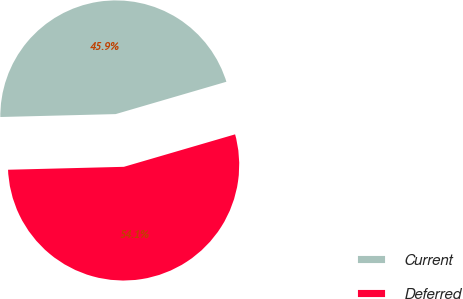<chart> <loc_0><loc_0><loc_500><loc_500><pie_chart><fcel>Current<fcel>Deferred<nl><fcel>45.88%<fcel>54.12%<nl></chart> 